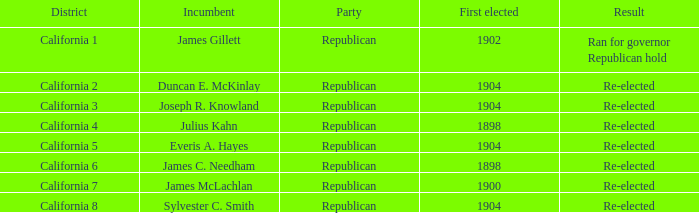Which Incumbent has a District of California 5? Everis A. Hayes. Would you mind parsing the complete table? {'header': ['District', 'Incumbent', 'Party', 'First elected', 'Result'], 'rows': [['California 1', 'James Gillett', 'Republican', '1902', 'Ran for governor Republican hold'], ['California 2', 'Duncan E. McKinlay', 'Republican', '1904', 'Re-elected'], ['California 3', 'Joseph R. Knowland', 'Republican', '1904', 'Re-elected'], ['California 4', 'Julius Kahn', 'Republican', '1898', 'Re-elected'], ['California 5', 'Everis A. Hayes', 'Republican', '1904', 'Re-elected'], ['California 6', 'James C. Needham', 'Republican', '1898', 'Re-elected'], ['California 7', 'James McLachlan', 'Republican', '1900', 'Re-elected'], ['California 8', 'Sylvester C. Smith', 'Republican', '1904', 'Re-elected']]} 